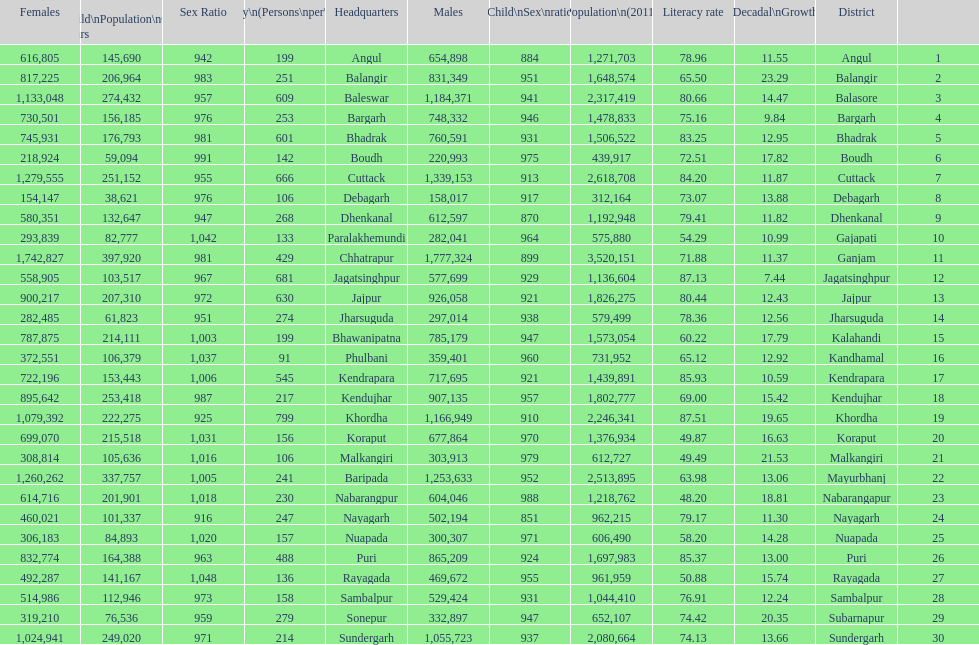Tell me a district that did not have a population over 600,000. Boudh. 